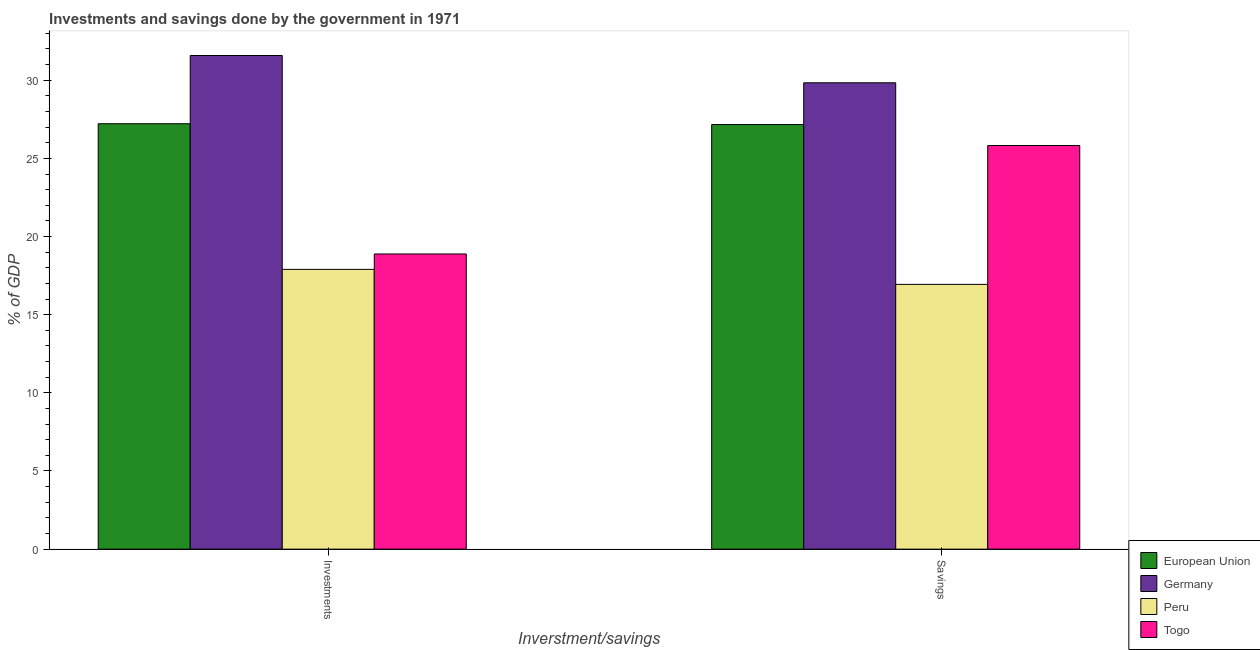Are the number of bars per tick equal to the number of legend labels?
Your response must be concise. Yes. What is the label of the 2nd group of bars from the left?
Your answer should be compact. Savings. What is the savings of government in Germany?
Keep it short and to the point. 29.84. Across all countries, what is the maximum savings of government?
Your answer should be compact. 29.84. Across all countries, what is the minimum investments of government?
Keep it short and to the point. 17.9. In which country was the savings of government maximum?
Keep it short and to the point. Germany. What is the total savings of government in the graph?
Provide a succinct answer. 99.77. What is the difference between the savings of government in European Union and that in Togo?
Make the answer very short. 1.34. What is the difference between the savings of government in Peru and the investments of government in Germany?
Offer a very short reply. -14.64. What is the average investments of government per country?
Your answer should be very brief. 23.9. What is the difference between the savings of government and investments of government in Togo?
Keep it short and to the point. 6.94. What is the ratio of the savings of government in Peru to that in Germany?
Provide a succinct answer. 0.57. In how many countries, is the investments of government greater than the average investments of government taken over all countries?
Ensure brevity in your answer.  2. What does the 4th bar from the left in Investments represents?
Your response must be concise. Togo. What does the 3rd bar from the right in Savings represents?
Your response must be concise. Germany. How many bars are there?
Make the answer very short. 8. Are all the bars in the graph horizontal?
Provide a short and direct response. No. How many countries are there in the graph?
Your answer should be very brief. 4. Does the graph contain any zero values?
Keep it short and to the point. No. Does the graph contain grids?
Your answer should be compact. No. How are the legend labels stacked?
Provide a short and direct response. Vertical. What is the title of the graph?
Your answer should be very brief. Investments and savings done by the government in 1971. Does "Monaco" appear as one of the legend labels in the graph?
Provide a succinct answer. No. What is the label or title of the X-axis?
Ensure brevity in your answer.  Inverstment/savings. What is the label or title of the Y-axis?
Provide a succinct answer. % of GDP. What is the % of GDP of European Union in Investments?
Your answer should be compact. 27.22. What is the % of GDP in Germany in Investments?
Offer a terse response. 31.58. What is the % of GDP of Peru in Investments?
Your answer should be very brief. 17.9. What is the % of GDP of Togo in Investments?
Provide a short and direct response. 18.88. What is the % of GDP in European Union in Savings?
Keep it short and to the point. 27.17. What is the % of GDP of Germany in Savings?
Give a very brief answer. 29.84. What is the % of GDP in Peru in Savings?
Your response must be concise. 16.94. What is the % of GDP of Togo in Savings?
Offer a terse response. 25.83. Across all Inverstment/savings, what is the maximum % of GDP of European Union?
Your answer should be compact. 27.22. Across all Inverstment/savings, what is the maximum % of GDP of Germany?
Ensure brevity in your answer.  31.58. Across all Inverstment/savings, what is the maximum % of GDP of Peru?
Your response must be concise. 17.9. Across all Inverstment/savings, what is the maximum % of GDP of Togo?
Provide a short and direct response. 25.83. Across all Inverstment/savings, what is the minimum % of GDP in European Union?
Make the answer very short. 27.17. Across all Inverstment/savings, what is the minimum % of GDP of Germany?
Make the answer very short. 29.84. Across all Inverstment/savings, what is the minimum % of GDP in Peru?
Your answer should be compact. 16.94. Across all Inverstment/savings, what is the minimum % of GDP of Togo?
Provide a short and direct response. 18.88. What is the total % of GDP of European Union in the graph?
Your answer should be compact. 54.38. What is the total % of GDP of Germany in the graph?
Offer a terse response. 61.42. What is the total % of GDP of Peru in the graph?
Your answer should be very brief. 34.84. What is the total % of GDP in Togo in the graph?
Provide a short and direct response. 44.71. What is the difference between the % of GDP of European Union in Investments and that in Savings?
Make the answer very short. 0.05. What is the difference between the % of GDP of Germany in Investments and that in Savings?
Make the answer very short. 1.75. What is the difference between the % of GDP in Peru in Investments and that in Savings?
Offer a terse response. 0.96. What is the difference between the % of GDP of Togo in Investments and that in Savings?
Your answer should be very brief. -6.94. What is the difference between the % of GDP in European Union in Investments and the % of GDP in Germany in Savings?
Your answer should be compact. -2.62. What is the difference between the % of GDP of European Union in Investments and the % of GDP of Peru in Savings?
Keep it short and to the point. 10.28. What is the difference between the % of GDP in European Union in Investments and the % of GDP in Togo in Savings?
Keep it short and to the point. 1.39. What is the difference between the % of GDP in Germany in Investments and the % of GDP in Peru in Savings?
Make the answer very short. 14.64. What is the difference between the % of GDP of Germany in Investments and the % of GDP of Togo in Savings?
Keep it short and to the point. 5.76. What is the difference between the % of GDP in Peru in Investments and the % of GDP in Togo in Savings?
Keep it short and to the point. -7.93. What is the average % of GDP of European Union per Inverstment/savings?
Ensure brevity in your answer.  27.19. What is the average % of GDP of Germany per Inverstment/savings?
Offer a terse response. 30.71. What is the average % of GDP of Peru per Inverstment/savings?
Give a very brief answer. 17.42. What is the average % of GDP of Togo per Inverstment/savings?
Give a very brief answer. 22.36. What is the difference between the % of GDP in European Union and % of GDP in Germany in Investments?
Give a very brief answer. -4.37. What is the difference between the % of GDP of European Union and % of GDP of Peru in Investments?
Offer a very short reply. 9.32. What is the difference between the % of GDP in European Union and % of GDP in Togo in Investments?
Your answer should be compact. 8.33. What is the difference between the % of GDP of Germany and % of GDP of Peru in Investments?
Give a very brief answer. 13.68. What is the difference between the % of GDP of Germany and % of GDP of Togo in Investments?
Ensure brevity in your answer.  12.7. What is the difference between the % of GDP in Peru and % of GDP in Togo in Investments?
Offer a very short reply. -0.99. What is the difference between the % of GDP of European Union and % of GDP of Germany in Savings?
Make the answer very short. -2.67. What is the difference between the % of GDP in European Union and % of GDP in Peru in Savings?
Keep it short and to the point. 10.23. What is the difference between the % of GDP of European Union and % of GDP of Togo in Savings?
Give a very brief answer. 1.34. What is the difference between the % of GDP of Germany and % of GDP of Peru in Savings?
Offer a very short reply. 12.9. What is the difference between the % of GDP of Germany and % of GDP of Togo in Savings?
Provide a succinct answer. 4.01. What is the difference between the % of GDP of Peru and % of GDP of Togo in Savings?
Your response must be concise. -8.89. What is the ratio of the % of GDP in Germany in Investments to that in Savings?
Offer a very short reply. 1.06. What is the ratio of the % of GDP of Peru in Investments to that in Savings?
Give a very brief answer. 1.06. What is the ratio of the % of GDP of Togo in Investments to that in Savings?
Your answer should be compact. 0.73. What is the difference between the highest and the second highest % of GDP of European Union?
Keep it short and to the point. 0.05. What is the difference between the highest and the second highest % of GDP of Germany?
Offer a terse response. 1.75. What is the difference between the highest and the second highest % of GDP in Peru?
Provide a succinct answer. 0.96. What is the difference between the highest and the second highest % of GDP in Togo?
Ensure brevity in your answer.  6.94. What is the difference between the highest and the lowest % of GDP of European Union?
Provide a succinct answer. 0.05. What is the difference between the highest and the lowest % of GDP of Germany?
Ensure brevity in your answer.  1.75. What is the difference between the highest and the lowest % of GDP in Peru?
Ensure brevity in your answer.  0.96. What is the difference between the highest and the lowest % of GDP in Togo?
Your answer should be compact. 6.94. 